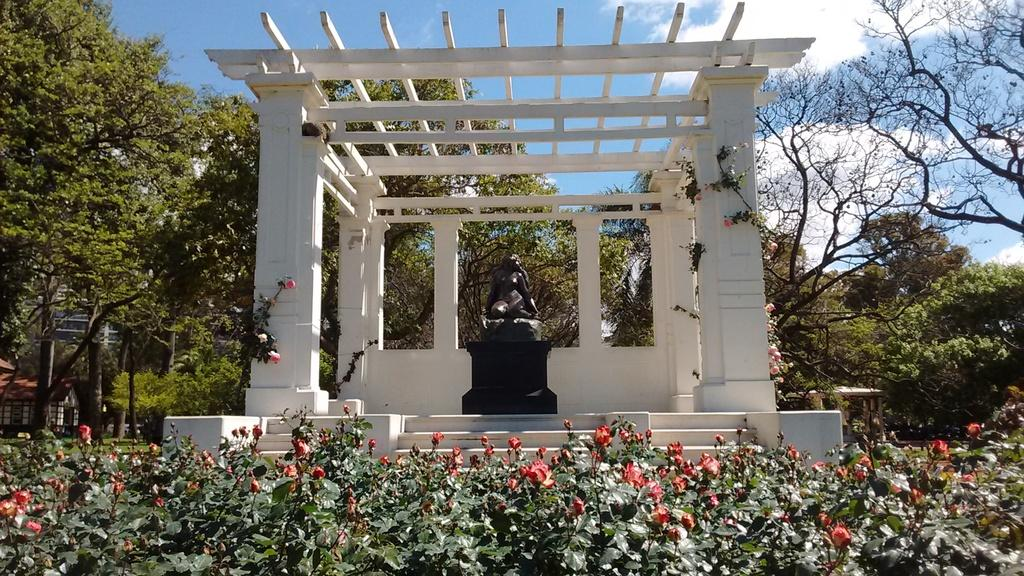What type of plants are present in the image? There are plants with flowers in the image. What is the architectural feature visible in the image? There is a pergola in the image. What type of structure can be seen in the background of the image? There is a house in the image. What type of vegetation is present in the image besides the plants? There are trees in the image. How would you describe the sky in the image? The sky is blue and has clouds in the background of the image. How many corks are scattered around the statue in the image? There are no corks present in the image. What type of war is depicted in the image? There is no depiction of war in the image. 